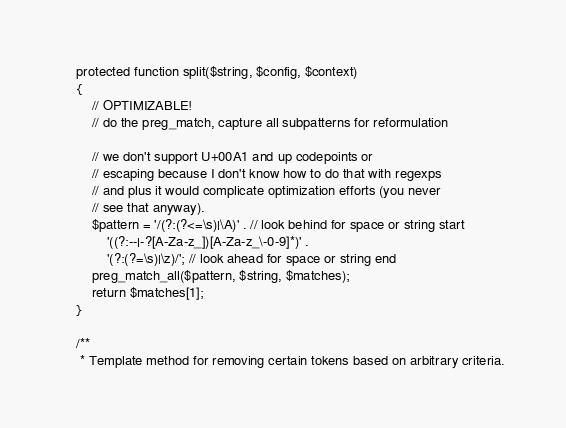<code> <loc_0><loc_0><loc_500><loc_500><_PHP_>    protected function split($string, $config, $context)
    {
        // OPTIMIZABLE!
        // do the preg_match, capture all subpatterns for reformulation

        // we don't support U+00A1 and up codepoints or
        // escaping because I don't know how to do that with regexps
        // and plus it would complicate optimization efforts (you never
        // see that anyway).
        $pattern = '/(?:(?<=\s)|\A)' . // look behind for space or string start
            '((?:--|-?[A-Za-z_])[A-Za-z_\-0-9]*)' .
            '(?:(?=\s)|\z)/'; // look ahead for space or string end
        preg_match_all($pattern, $string, $matches);
        return $matches[1];
    }

    /**
     * Template method for removing certain tokens based on arbitrary criteria.</code> 